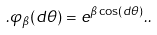Convert formula to latex. <formula><loc_0><loc_0><loc_500><loc_500>. \varphi _ { \beta } ( d \theta ) = e ^ { \beta \cos ( d \theta ) } . .</formula> 